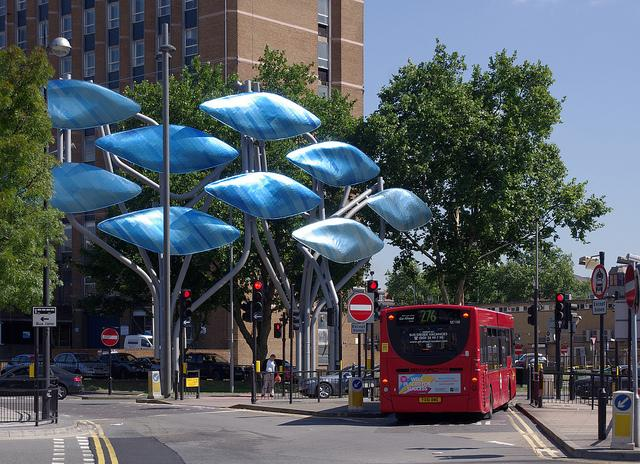What type of art is this? modern 